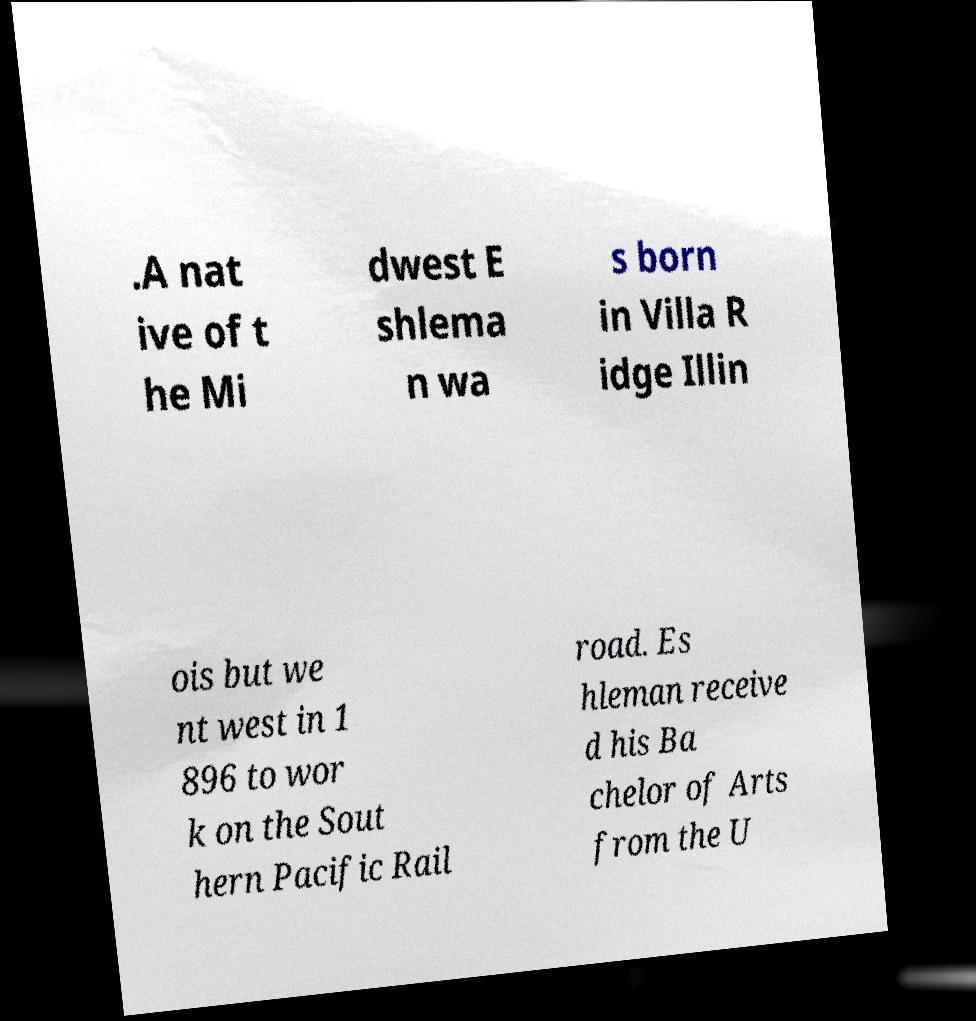For documentation purposes, I need the text within this image transcribed. Could you provide that? .A nat ive of t he Mi dwest E shlema n wa s born in Villa R idge Illin ois but we nt west in 1 896 to wor k on the Sout hern Pacific Rail road. Es hleman receive d his Ba chelor of Arts from the U 